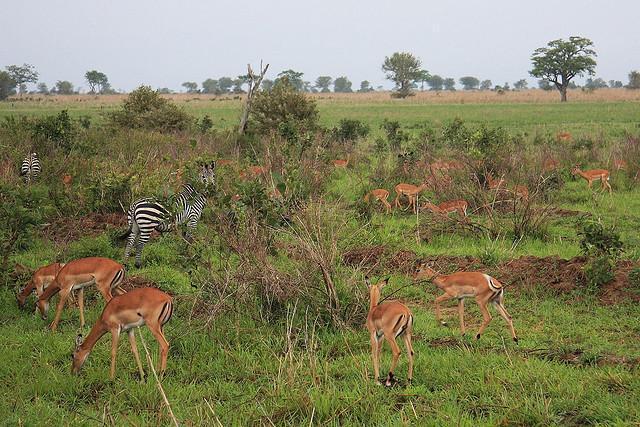How many different animals is in the photo?
Give a very brief answer. 2. 